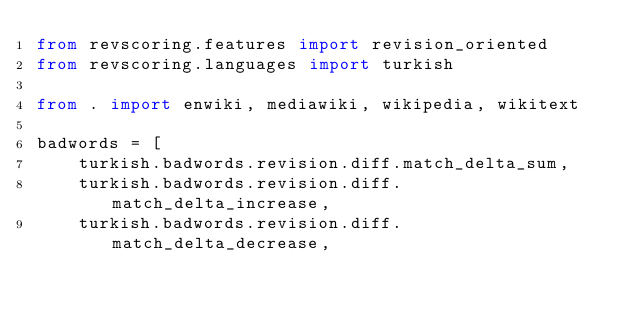<code> <loc_0><loc_0><loc_500><loc_500><_Python_>from revscoring.features import revision_oriented
from revscoring.languages import turkish

from . import enwiki, mediawiki, wikipedia, wikitext

badwords = [
    turkish.badwords.revision.diff.match_delta_sum,
    turkish.badwords.revision.diff.match_delta_increase,
    turkish.badwords.revision.diff.match_delta_decrease,</code> 